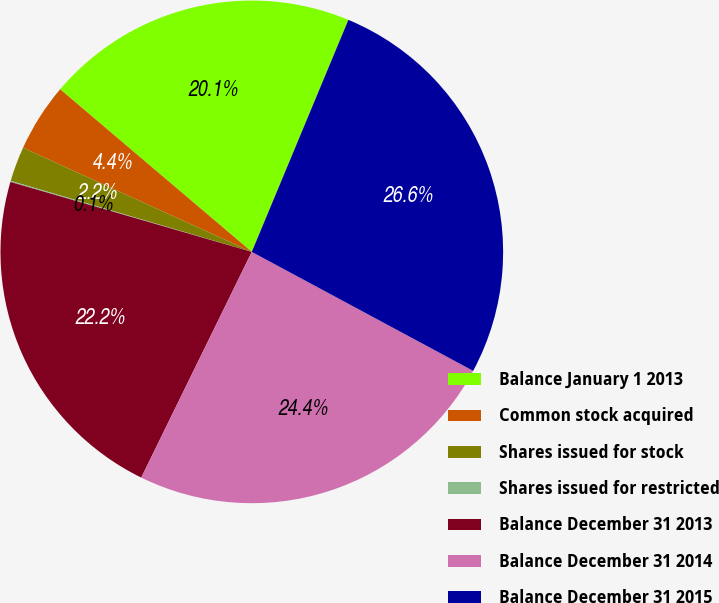<chart> <loc_0><loc_0><loc_500><loc_500><pie_chart><fcel>Balance January 1 2013<fcel>Common stock acquired<fcel>Shares issued for stock<fcel>Shares issued for restricted<fcel>Balance December 31 2013<fcel>Balance December 31 2014<fcel>Balance December 31 2015<nl><fcel>20.08%<fcel>4.4%<fcel>2.24%<fcel>0.07%<fcel>22.24%<fcel>24.4%<fcel>26.57%<nl></chart> 